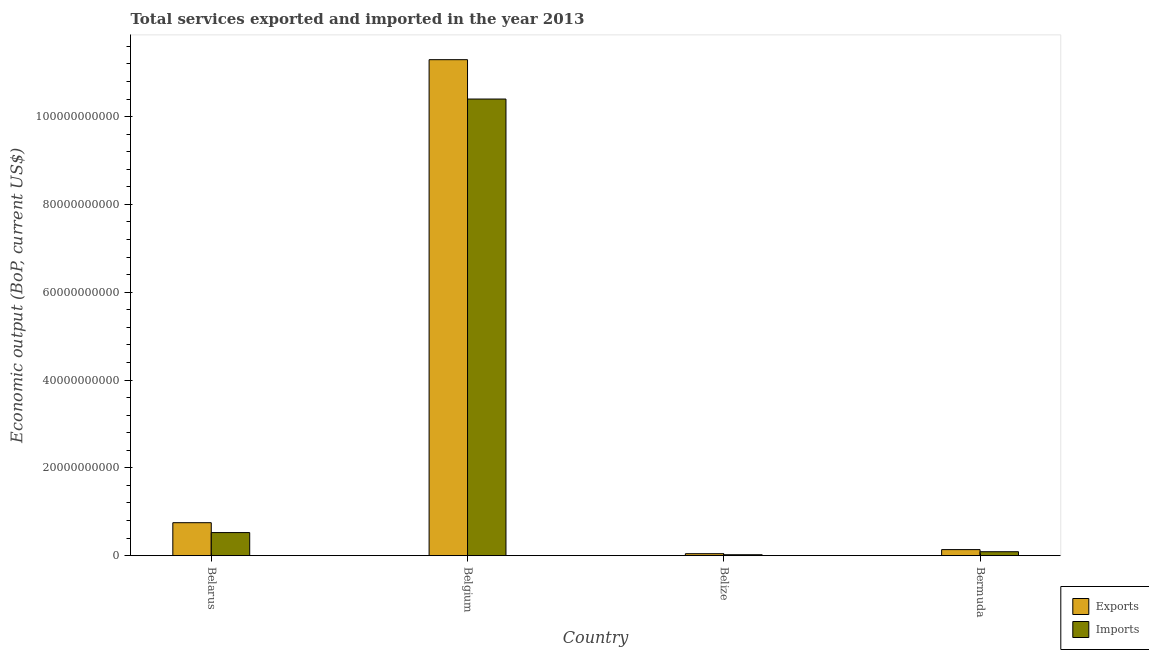How many different coloured bars are there?
Give a very brief answer. 2. How many groups of bars are there?
Ensure brevity in your answer.  4. Are the number of bars on each tick of the X-axis equal?
Your answer should be compact. Yes. How many bars are there on the 4th tick from the left?
Ensure brevity in your answer.  2. How many bars are there on the 2nd tick from the right?
Make the answer very short. 2. What is the label of the 4th group of bars from the left?
Ensure brevity in your answer.  Bermuda. What is the amount of service exports in Bermuda?
Keep it short and to the point. 1.38e+09. Across all countries, what is the maximum amount of service exports?
Keep it short and to the point. 1.13e+11. Across all countries, what is the minimum amount of service exports?
Your answer should be compact. 4.48e+08. In which country was the amount of service imports maximum?
Provide a short and direct response. Belgium. In which country was the amount of service exports minimum?
Provide a short and direct response. Belize. What is the total amount of service exports in the graph?
Offer a terse response. 1.22e+11. What is the difference between the amount of service exports in Belize and that in Bermuda?
Provide a succinct answer. -9.30e+08. What is the difference between the amount of service exports in Belarus and the amount of service imports in Belize?
Offer a very short reply. 7.30e+09. What is the average amount of service imports per country?
Make the answer very short. 2.76e+1. What is the difference between the amount of service exports and amount of service imports in Belarus?
Your answer should be compact. 2.25e+09. What is the ratio of the amount of service imports in Belarus to that in Belgium?
Your answer should be compact. 0.05. Is the amount of service imports in Belgium less than that in Belize?
Your response must be concise. No. Is the difference between the amount of service imports in Belgium and Belize greater than the difference between the amount of service exports in Belgium and Belize?
Keep it short and to the point. No. What is the difference between the highest and the second highest amount of service imports?
Your response must be concise. 9.87e+1. What is the difference between the highest and the lowest amount of service exports?
Your response must be concise. 1.13e+11. Is the sum of the amount of service imports in Belgium and Bermuda greater than the maximum amount of service exports across all countries?
Ensure brevity in your answer.  No. What does the 1st bar from the left in Bermuda represents?
Make the answer very short. Exports. What does the 2nd bar from the right in Belarus represents?
Your response must be concise. Exports. How many bars are there?
Ensure brevity in your answer.  8. How many countries are there in the graph?
Your answer should be compact. 4. What is the difference between two consecutive major ticks on the Y-axis?
Give a very brief answer. 2.00e+1. Are the values on the major ticks of Y-axis written in scientific E-notation?
Your answer should be compact. No. Does the graph contain any zero values?
Provide a short and direct response. No. What is the title of the graph?
Keep it short and to the point. Total services exported and imported in the year 2013. Does "Girls" appear as one of the legend labels in the graph?
Make the answer very short. No. What is the label or title of the Y-axis?
Your response must be concise. Economic output (BoP, current US$). What is the Economic output (BoP, current US$) of Exports in Belarus?
Offer a very short reply. 7.51e+09. What is the Economic output (BoP, current US$) in Imports in Belarus?
Offer a terse response. 5.25e+09. What is the Economic output (BoP, current US$) in Exports in Belgium?
Your response must be concise. 1.13e+11. What is the Economic output (BoP, current US$) in Imports in Belgium?
Keep it short and to the point. 1.04e+11. What is the Economic output (BoP, current US$) in Exports in Belize?
Make the answer very short. 4.48e+08. What is the Economic output (BoP, current US$) of Imports in Belize?
Offer a very short reply. 2.08e+08. What is the Economic output (BoP, current US$) of Exports in Bermuda?
Make the answer very short. 1.38e+09. What is the Economic output (BoP, current US$) in Imports in Bermuda?
Keep it short and to the point. 8.95e+08. Across all countries, what is the maximum Economic output (BoP, current US$) of Exports?
Ensure brevity in your answer.  1.13e+11. Across all countries, what is the maximum Economic output (BoP, current US$) of Imports?
Your answer should be compact. 1.04e+11. Across all countries, what is the minimum Economic output (BoP, current US$) in Exports?
Your answer should be compact. 4.48e+08. Across all countries, what is the minimum Economic output (BoP, current US$) in Imports?
Ensure brevity in your answer.  2.08e+08. What is the total Economic output (BoP, current US$) of Exports in the graph?
Make the answer very short. 1.22e+11. What is the total Economic output (BoP, current US$) in Imports in the graph?
Provide a succinct answer. 1.10e+11. What is the difference between the Economic output (BoP, current US$) of Exports in Belarus and that in Belgium?
Keep it short and to the point. -1.05e+11. What is the difference between the Economic output (BoP, current US$) of Imports in Belarus and that in Belgium?
Your answer should be very brief. -9.87e+1. What is the difference between the Economic output (BoP, current US$) of Exports in Belarus and that in Belize?
Offer a very short reply. 7.06e+09. What is the difference between the Economic output (BoP, current US$) in Imports in Belarus and that in Belize?
Offer a terse response. 5.05e+09. What is the difference between the Economic output (BoP, current US$) of Exports in Belarus and that in Bermuda?
Offer a very short reply. 6.13e+09. What is the difference between the Economic output (BoP, current US$) of Imports in Belarus and that in Bermuda?
Your answer should be very brief. 4.36e+09. What is the difference between the Economic output (BoP, current US$) of Exports in Belgium and that in Belize?
Give a very brief answer. 1.13e+11. What is the difference between the Economic output (BoP, current US$) of Imports in Belgium and that in Belize?
Offer a very short reply. 1.04e+11. What is the difference between the Economic output (BoP, current US$) in Exports in Belgium and that in Bermuda?
Offer a very short reply. 1.12e+11. What is the difference between the Economic output (BoP, current US$) in Imports in Belgium and that in Bermuda?
Ensure brevity in your answer.  1.03e+11. What is the difference between the Economic output (BoP, current US$) of Exports in Belize and that in Bermuda?
Your answer should be compact. -9.30e+08. What is the difference between the Economic output (BoP, current US$) in Imports in Belize and that in Bermuda?
Your response must be concise. -6.88e+08. What is the difference between the Economic output (BoP, current US$) of Exports in Belarus and the Economic output (BoP, current US$) of Imports in Belgium?
Give a very brief answer. -9.65e+1. What is the difference between the Economic output (BoP, current US$) in Exports in Belarus and the Economic output (BoP, current US$) in Imports in Belize?
Your response must be concise. 7.30e+09. What is the difference between the Economic output (BoP, current US$) in Exports in Belarus and the Economic output (BoP, current US$) in Imports in Bermuda?
Provide a short and direct response. 6.61e+09. What is the difference between the Economic output (BoP, current US$) of Exports in Belgium and the Economic output (BoP, current US$) of Imports in Belize?
Provide a short and direct response. 1.13e+11. What is the difference between the Economic output (BoP, current US$) in Exports in Belgium and the Economic output (BoP, current US$) in Imports in Bermuda?
Your answer should be compact. 1.12e+11. What is the difference between the Economic output (BoP, current US$) of Exports in Belize and the Economic output (BoP, current US$) of Imports in Bermuda?
Ensure brevity in your answer.  -4.47e+08. What is the average Economic output (BoP, current US$) in Exports per country?
Offer a terse response. 3.06e+1. What is the average Economic output (BoP, current US$) in Imports per country?
Keep it short and to the point. 2.76e+1. What is the difference between the Economic output (BoP, current US$) in Exports and Economic output (BoP, current US$) in Imports in Belarus?
Keep it short and to the point. 2.25e+09. What is the difference between the Economic output (BoP, current US$) of Exports and Economic output (BoP, current US$) of Imports in Belgium?
Your answer should be compact. 8.97e+09. What is the difference between the Economic output (BoP, current US$) in Exports and Economic output (BoP, current US$) in Imports in Belize?
Provide a short and direct response. 2.40e+08. What is the difference between the Economic output (BoP, current US$) in Exports and Economic output (BoP, current US$) in Imports in Bermuda?
Your response must be concise. 4.83e+08. What is the ratio of the Economic output (BoP, current US$) in Exports in Belarus to that in Belgium?
Offer a terse response. 0.07. What is the ratio of the Economic output (BoP, current US$) of Imports in Belarus to that in Belgium?
Keep it short and to the point. 0.05. What is the ratio of the Economic output (BoP, current US$) in Exports in Belarus to that in Belize?
Your answer should be compact. 16.75. What is the ratio of the Economic output (BoP, current US$) in Imports in Belarus to that in Belize?
Keep it short and to the point. 25.28. What is the ratio of the Economic output (BoP, current US$) in Exports in Belarus to that in Bermuda?
Your answer should be very brief. 5.45. What is the ratio of the Economic output (BoP, current US$) of Imports in Belarus to that in Bermuda?
Your answer should be compact. 5.87. What is the ratio of the Economic output (BoP, current US$) of Exports in Belgium to that in Belize?
Make the answer very short. 252.11. What is the ratio of the Economic output (BoP, current US$) of Imports in Belgium to that in Belize?
Offer a very short reply. 500.46. What is the ratio of the Economic output (BoP, current US$) of Exports in Belgium to that in Bermuda?
Offer a very short reply. 81.95. What is the ratio of the Economic output (BoP, current US$) of Imports in Belgium to that in Bermuda?
Give a very brief answer. 116.13. What is the ratio of the Economic output (BoP, current US$) in Exports in Belize to that in Bermuda?
Offer a very short reply. 0.33. What is the ratio of the Economic output (BoP, current US$) in Imports in Belize to that in Bermuda?
Offer a terse response. 0.23. What is the difference between the highest and the second highest Economic output (BoP, current US$) of Exports?
Make the answer very short. 1.05e+11. What is the difference between the highest and the second highest Economic output (BoP, current US$) in Imports?
Ensure brevity in your answer.  9.87e+1. What is the difference between the highest and the lowest Economic output (BoP, current US$) in Exports?
Give a very brief answer. 1.13e+11. What is the difference between the highest and the lowest Economic output (BoP, current US$) in Imports?
Give a very brief answer. 1.04e+11. 